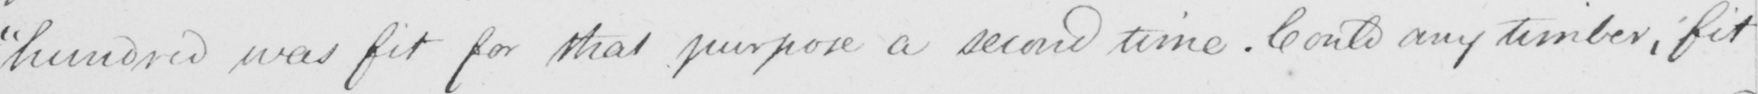Can you tell me what this handwritten text says? hundred was fit for that purpose a second time . Could any timber , fit 